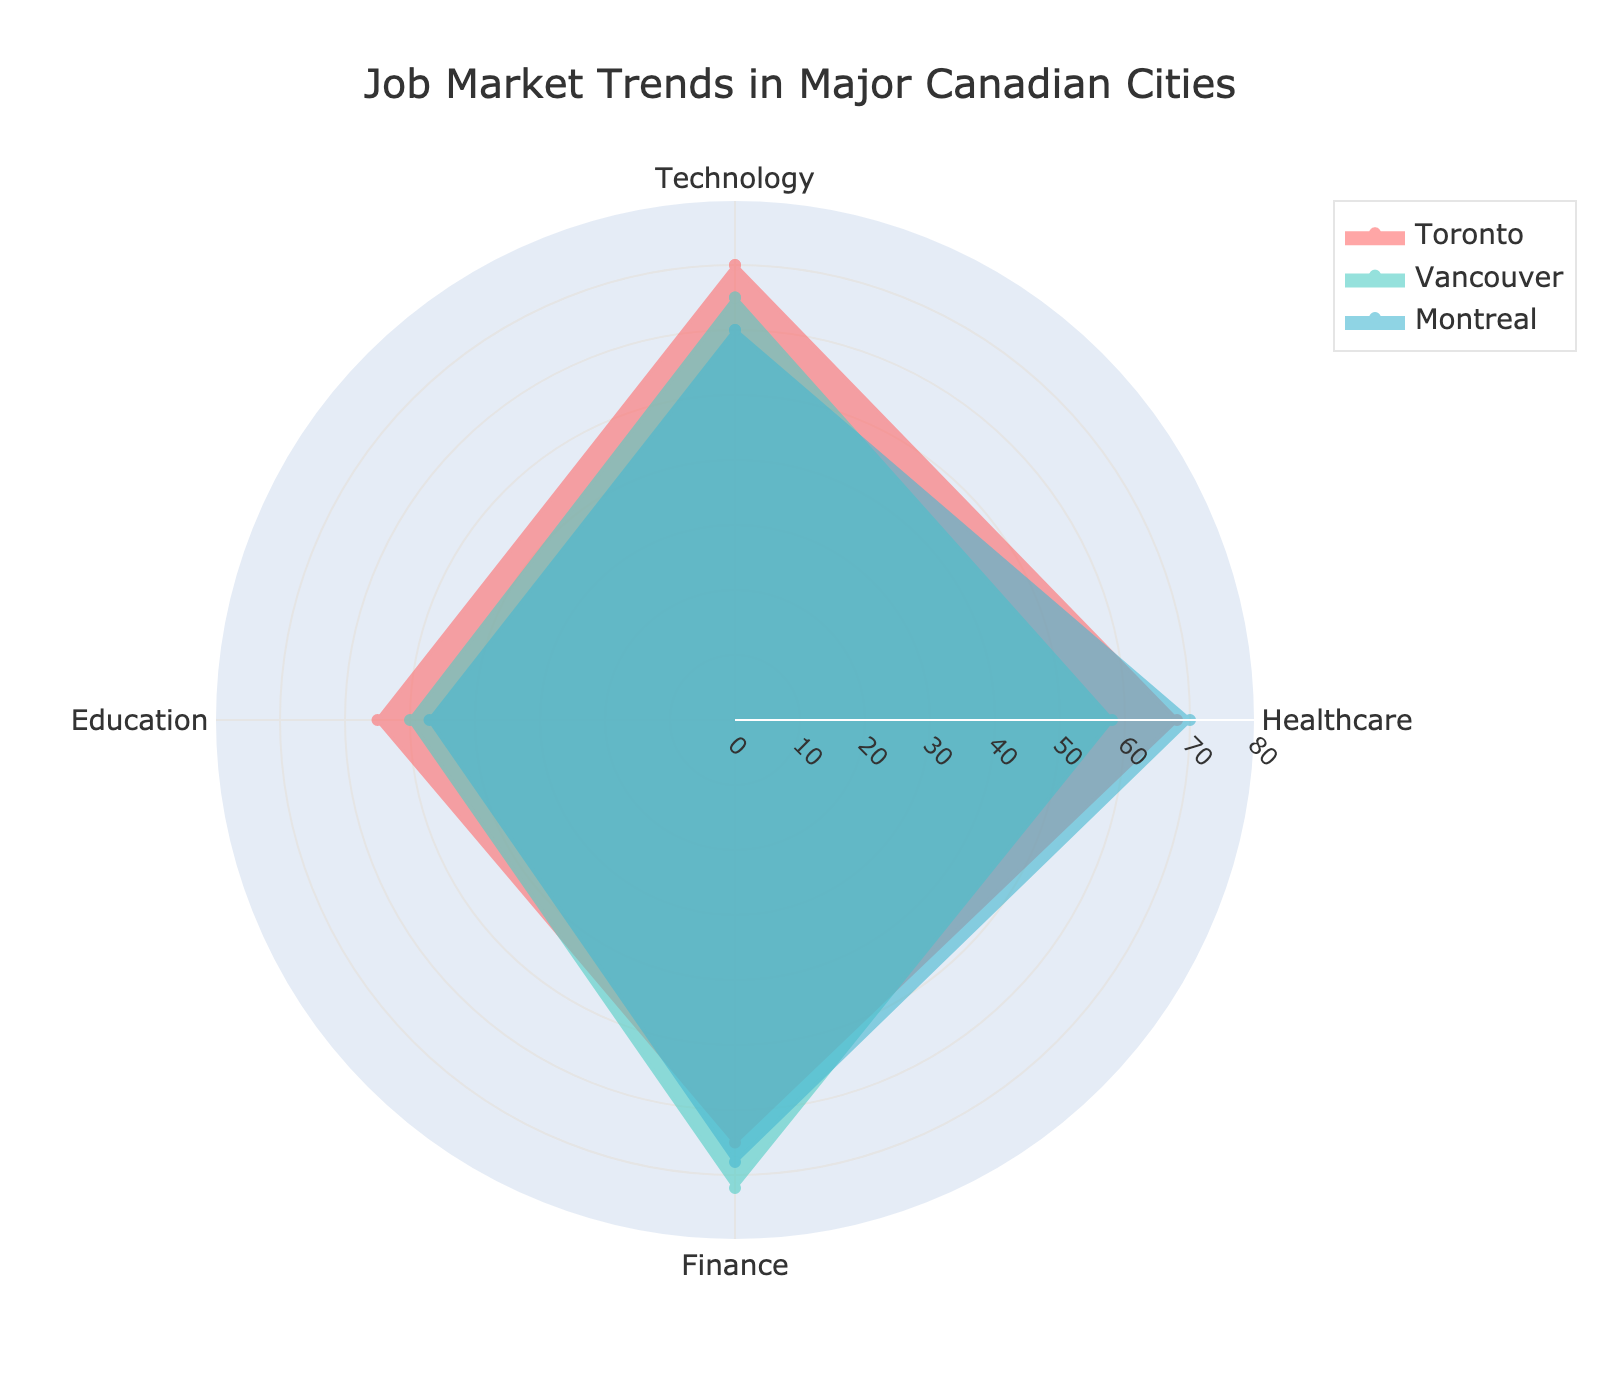What is the title of the radar chart? The title is located at the top of the chart and summarizes what the chart is about. It reads "Job Market Trends in Major Canadian Cities."
Answer: Job Market Trends in Major Canadian Cities Which city has the highest score in the Finance sector? By observing the chart, look for the highest radial value in the Finance sector for each city. The highest point in Finance belongs to Vancouver.
Answer: Vancouver Across all displayed cities, which sector appears the most balanced (i.e., with the least variation in values)? Check the spread of the values for each sector across Toronto, Vancouver, and Montreal. Healthcare values (68, 58, 70) have less variation compared to other sectors.
Answer: Healthcare Which city shows the greatest discrepancy between Technology and Education sectors? Calculate the differences between Technology and Education values for each city: Toronto (70-55=15), Vancouver (65-50=15), Montreal (60-47=13). Toronto and Vancouver tie for the greatest discrepancy.
Answer: Toronto and Vancouver What is the average score for Montreal across all sectors? Add the values for Montreal (60, 70, 68, 47), then divide by the number of sectors (4). (60+70+68+47)/4 = 61.25
Answer: 61.25 Between Toronto and Montreal, which city fares better in the Technology sector? Compare the Technology scores for Toronto and Montreal. Toronto has a score of 70, while Montreal has a score of 60.
Answer: Toronto What is the range of values for the Healthcare sector across all displayed cities? Identify the highest and lowest values in Healthcare across Toronto, Vancouver, and Montreal (70, 58, 70), then calculate the difference. The range is 70-58 = 12.
Answer: 12 Which city has the lowest value in the Education sector, and what is that value? Examine the Education values for Toronto, Vancouver, and Montreal. Montreal has the lowest value with 47.
Answer: Montreal, 47 If the chart included a city with the following scores: Technology=75, Healthcare=60, Finance=65, Education=45, how would this hypothetical city rank in the Technology sector alone compared to the three displayed cities? Compare the hypothetical city’s Technology score with those of Toronto (70), Vancouver (65), and Montreal (60). The hypothetical city, with a score of 75, ranks the highest.
Answer: Highest 